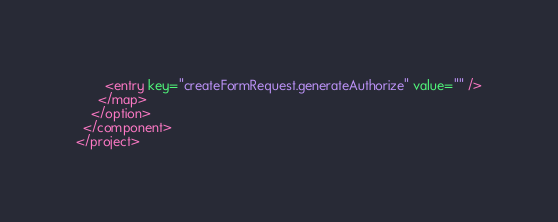Convert code to text. <code><loc_0><loc_0><loc_500><loc_500><_XML_>        <entry key="createFormRequest.generateAuthorize" value="" />
      </map>
    </option>
  </component>
</project></code> 